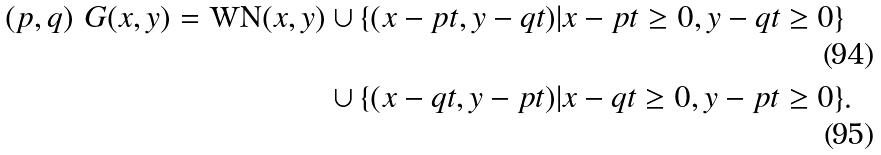Convert formula to latex. <formula><loc_0><loc_0><loc_500><loc_500>( p , q ) \ G ( x , y ) = \text {WN} ( x , y ) & \cup \{ ( x - p t , y - q t ) | x - p t \geq 0 , y - q t \geq 0 \} \\ & \cup \{ ( x - q t , y - p t ) | x - q t \geq 0 , y - p t \geq 0 \} .</formula> 